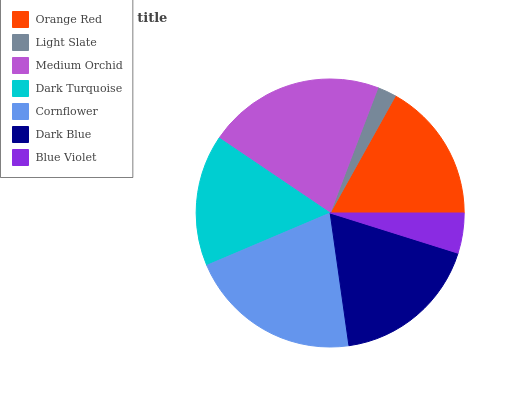Is Light Slate the minimum?
Answer yes or no. Yes. Is Medium Orchid the maximum?
Answer yes or no. Yes. Is Medium Orchid the minimum?
Answer yes or no. No. Is Light Slate the maximum?
Answer yes or no. No. Is Medium Orchid greater than Light Slate?
Answer yes or no. Yes. Is Light Slate less than Medium Orchid?
Answer yes or no. Yes. Is Light Slate greater than Medium Orchid?
Answer yes or no. No. Is Medium Orchid less than Light Slate?
Answer yes or no. No. Is Orange Red the high median?
Answer yes or no. Yes. Is Orange Red the low median?
Answer yes or no. Yes. Is Cornflower the high median?
Answer yes or no. No. Is Blue Violet the low median?
Answer yes or no. No. 